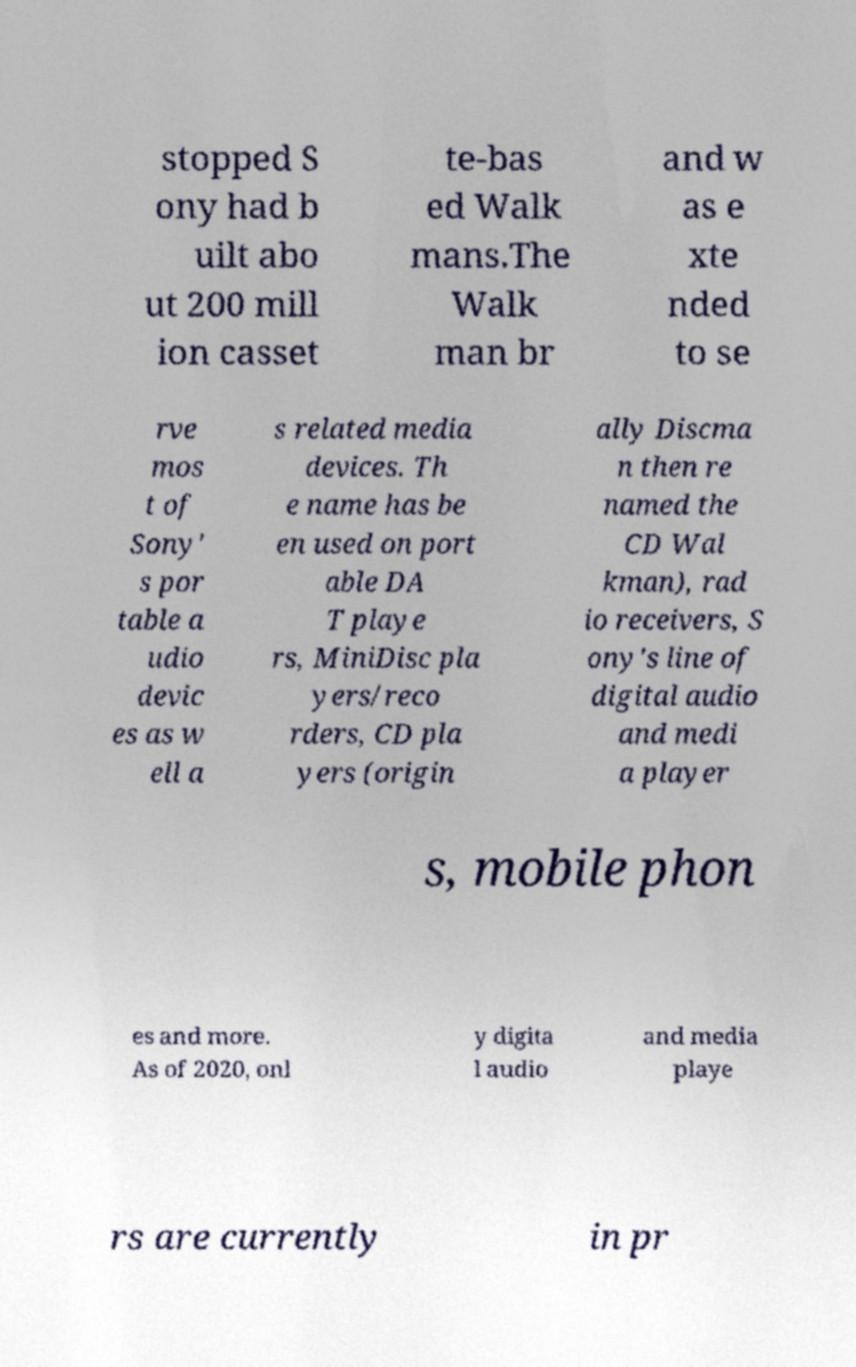Can you read and provide the text displayed in the image?This photo seems to have some interesting text. Can you extract and type it out for me? stopped S ony had b uilt abo ut 200 mill ion casset te-bas ed Walk mans.The Walk man br and w as e xte nded to se rve mos t of Sony' s por table a udio devic es as w ell a s related media devices. Th e name has be en used on port able DA T playe rs, MiniDisc pla yers/reco rders, CD pla yers (origin ally Discma n then re named the CD Wal kman), rad io receivers, S ony's line of digital audio and medi a player s, mobile phon es and more. As of 2020, onl y digita l audio and media playe rs are currently in pr 